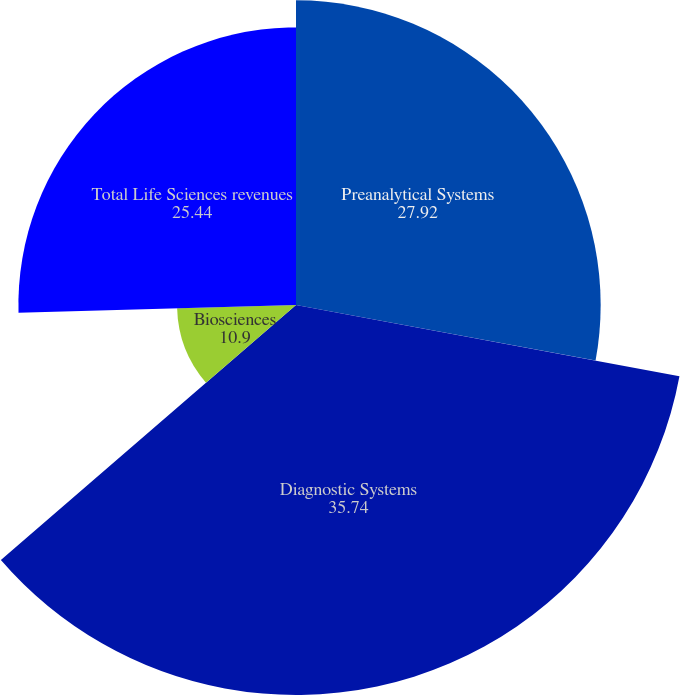Convert chart. <chart><loc_0><loc_0><loc_500><loc_500><pie_chart><fcel>Preanalytical Systems<fcel>Diagnostic Systems<fcel>Biosciences<fcel>Total Life Sciences revenues<nl><fcel>27.92%<fcel>35.74%<fcel>10.9%<fcel>25.44%<nl></chart> 